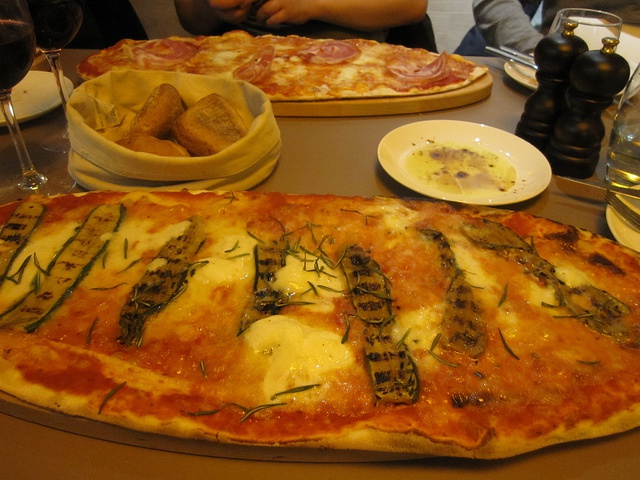Describe the objects in this image and their specific colors. I can see dining table in brown, maroon, black, and orange tones, pizza in black, red, maroon, and orange tones, bowl in black, olive, maroon, and orange tones, pizza in black, red, tan, orange, and maroon tones, and people in black, maroon, darkgray, and brown tones in this image. 